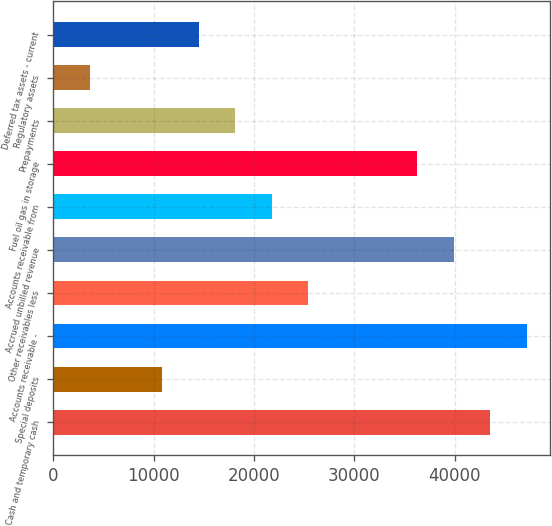<chart> <loc_0><loc_0><loc_500><loc_500><bar_chart><fcel>Cash and temporary cash<fcel>Special deposits<fcel>Accounts receivable -<fcel>Other receivables less<fcel>Accrued unbilled revenue<fcel>Accounts receivable from<fcel>Fuel oil gas in storage<fcel>Prepayments<fcel>Regulatory assets<fcel>Deferred tax assets - current<nl><fcel>43508.8<fcel>10880.2<fcel>47134.2<fcel>25381.8<fcel>39883.4<fcel>21756.4<fcel>36258<fcel>18131<fcel>3629.4<fcel>14505.6<nl></chart> 